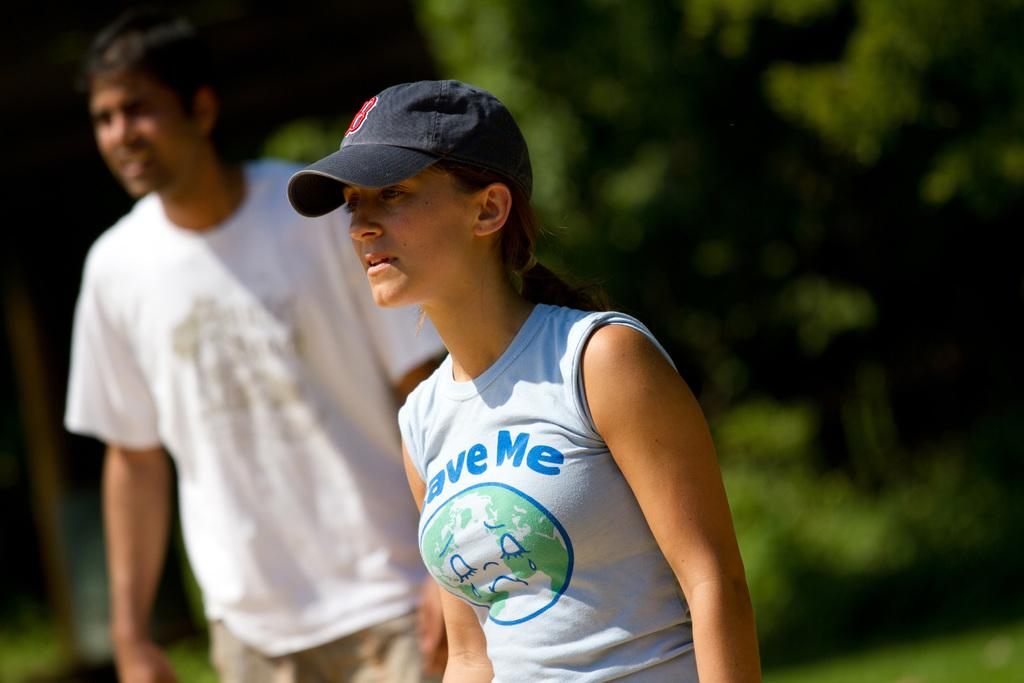<image>
Share a concise interpretation of the image provided. A woman in a sleeveless shirt that says "save me" is wearing a baseball cap. 